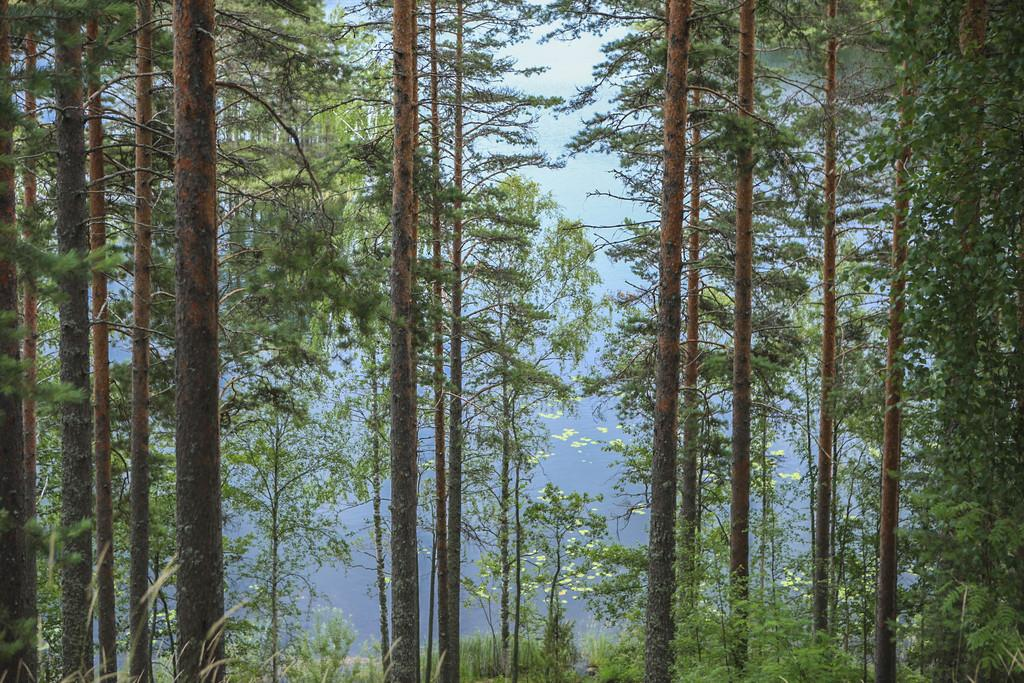What type of trees can be seen in the image? There are long branch trees in the image. Are there any other types of plants besides the long branch trees? Yes, there are plants besides the long branch trees in the image. What type of stocking is hanging from the long branch trees in the image? There is no stocking hanging from the long branch trees in the image. 